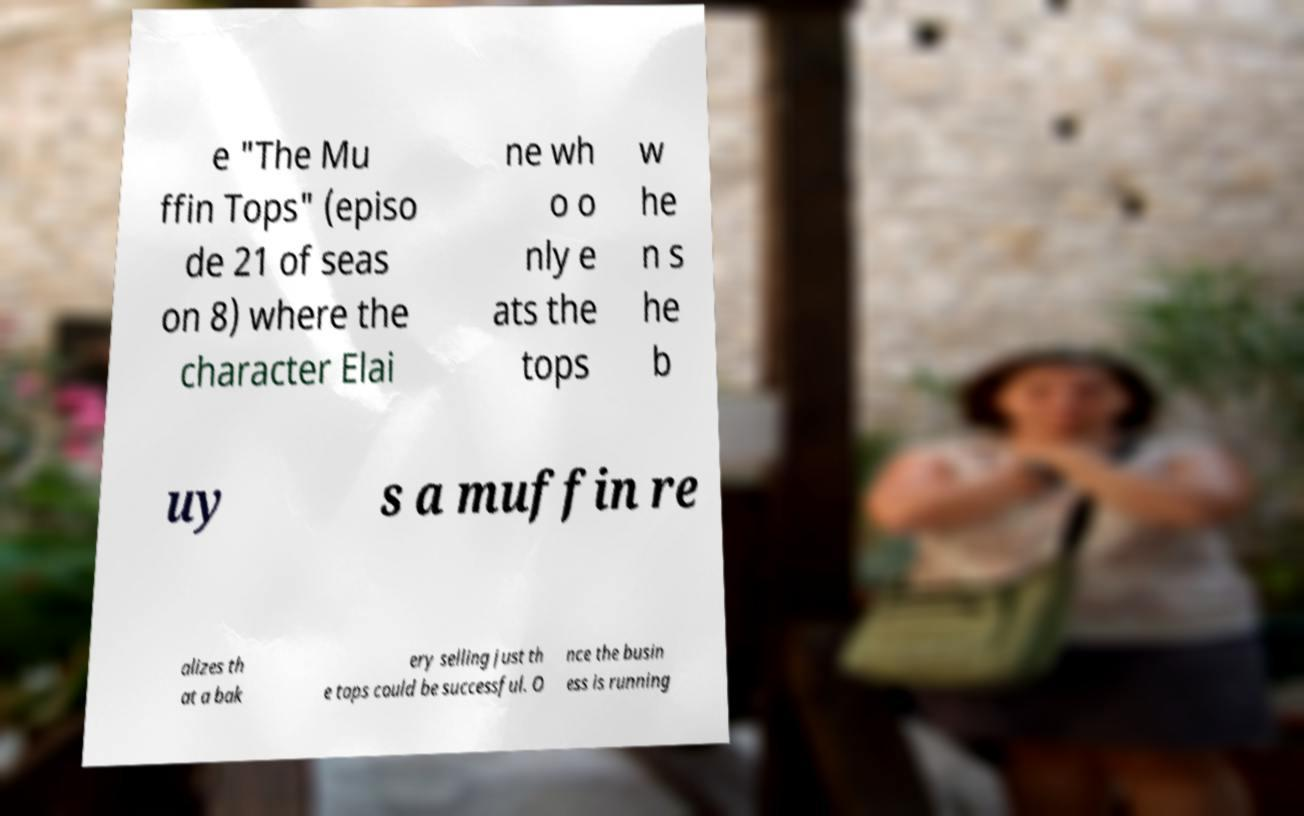There's text embedded in this image that I need extracted. Can you transcribe it verbatim? e "The Mu ffin Tops" (episo de 21 of seas on 8) where the character Elai ne wh o o nly e ats the tops w he n s he b uy s a muffin re alizes th at a bak ery selling just th e tops could be successful. O nce the busin ess is running 